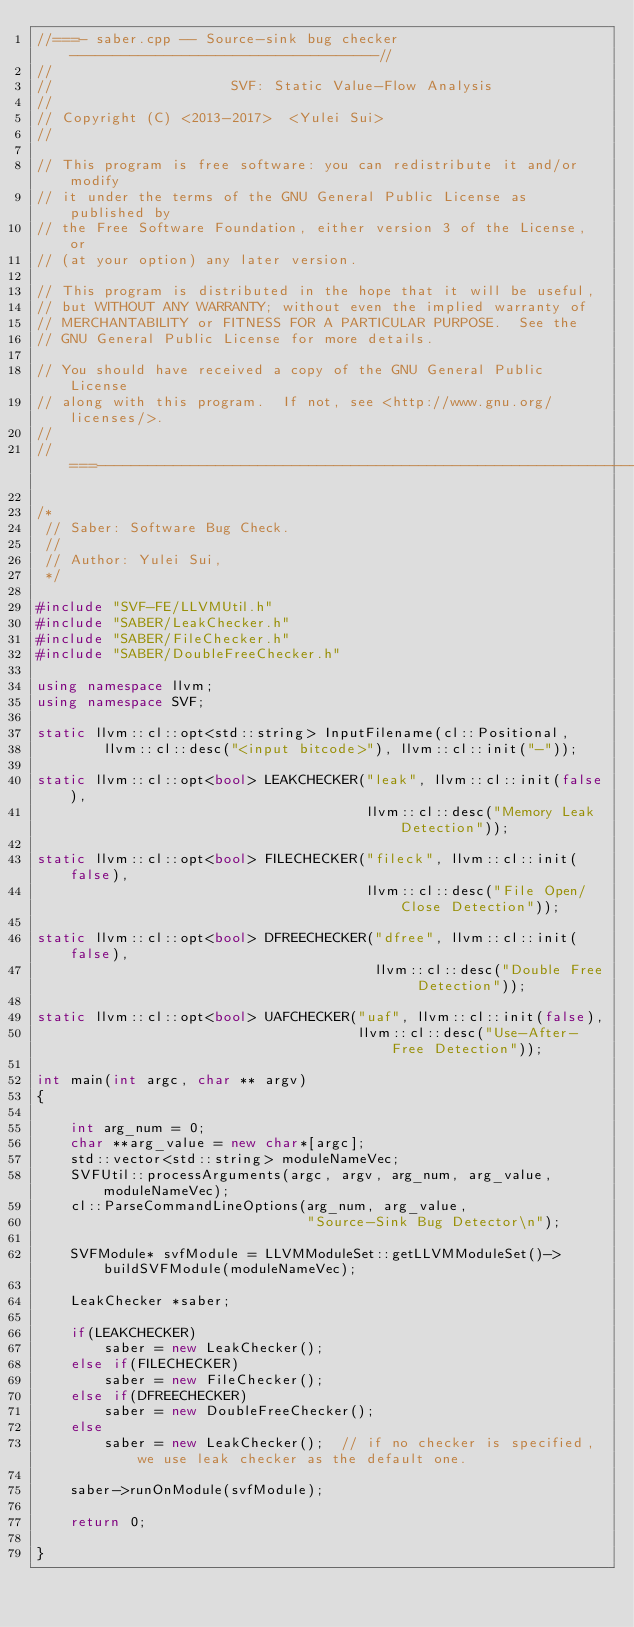<code> <loc_0><loc_0><loc_500><loc_500><_C++_>//===- saber.cpp -- Source-sink bug checker------------------------------------//
//
//                     SVF: Static Value-Flow Analysis
//
// Copyright (C) <2013-2017>  <Yulei Sui>
//

// This program is free software: you can redistribute it and/or modify
// it under the terms of the GNU General Public License as published by
// the Free Software Foundation, either version 3 of the License, or
// (at your option) any later version.

// This program is distributed in the hope that it will be useful,
// but WITHOUT ANY WARRANTY; without even the implied warranty of
// MERCHANTABILITY or FITNESS FOR A PARTICULAR PURPOSE.  See the
// GNU General Public License for more details.

// You should have received a copy of the GNU General Public License
// along with this program.  If not, see <http://www.gnu.org/licenses/>.
//
//===-----------------------------------------------------------------------===//

/*
 // Saber: Software Bug Check.
 //
 // Author: Yulei Sui,
 */

#include "SVF-FE/LLVMUtil.h"
#include "SABER/LeakChecker.h"
#include "SABER/FileChecker.h"
#include "SABER/DoubleFreeChecker.h"

using namespace llvm;
using namespace SVF;

static llvm::cl::opt<std::string> InputFilename(cl::Positional,
        llvm::cl::desc("<input bitcode>"), llvm::cl::init("-"));

static llvm::cl::opt<bool> LEAKCHECKER("leak", llvm::cl::init(false),
                                       llvm::cl::desc("Memory Leak Detection"));

static llvm::cl::opt<bool> FILECHECKER("fileck", llvm::cl::init(false),
                                       llvm::cl::desc("File Open/Close Detection"));

static llvm::cl::opt<bool> DFREECHECKER("dfree", llvm::cl::init(false),
                                        llvm::cl::desc("Double Free Detection"));

static llvm::cl::opt<bool> UAFCHECKER("uaf", llvm::cl::init(false),
                                      llvm::cl::desc("Use-After-Free Detection"));

int main(int argc, char ** argv)
{

    int arg_num = 0;
    char **arg_value = new char*[argc];
    std::vector<std::string> moduleNameVec;
    SVFUtil::processArguments(argc, argv, arg_num, arg_value, moduleNameVec);
    cl::ParseCommandLineOptions(arg_num, arg_value,
                                "Source-Sink Bug Detector\n");

    SVFModule* svfModule = LLVMModuleSet::getLLVMModuleSet()->buildSVFModule(moduleNameVec);

    LeakChecker *saber;

    if(LEAKCHECKER)
        saber = new LeakChecker();
    else if(FILECHECKER)
        saber = new FileChecker();
    else if(DFREECHECKER)
        saber = new DoubleFreeChecker();
    else
        saber = new LeakChecker();  // if no checker is specified, we use leak checker as the default one.

    saber->runOnModule(svfModule);

    return 0;

}
</code> 